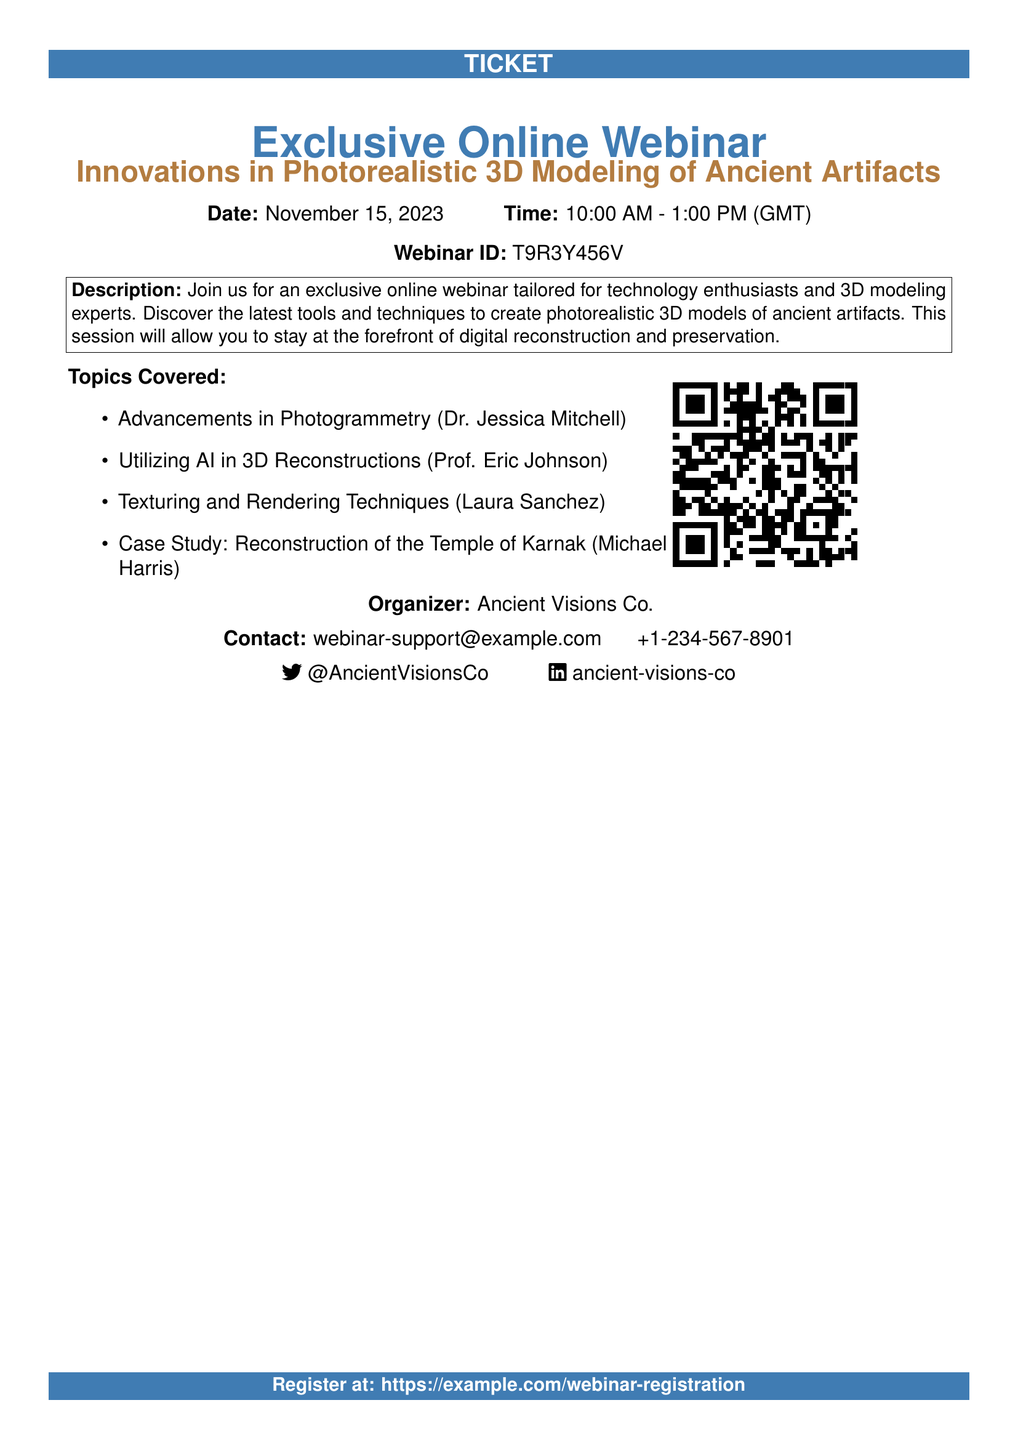What is the date of the webinar? The date of the webinar is explicitly stated in the document.
Answer: November 15, 2023 What is the time duration of the webinar? The document provides both the start time and end time of the webinar, which can be used to calculate the duration.
Answer: 3 hours What is the Webinar ID? The document specifies a unique identifier for the webinar for registration purposes.
Answer: T9R3Y456V Which organization is hosting the webinar? The document clearly states the organizer of the webinar.
Answer: Ancient Visions Co What is the contact email for the webinar? The document includes a contact email for inquiries related to the webinar.
Answer: webinar-support@example.com How do you register for the webinar? The document provides a URL for registration at the bottom.
Answer: https://example.com/webinar-registration What is one of the topics covered in the webinar? The document lists several topics, any of which can be answered as an example.
Answer: Utilizing AI in 3D Reconstructions 